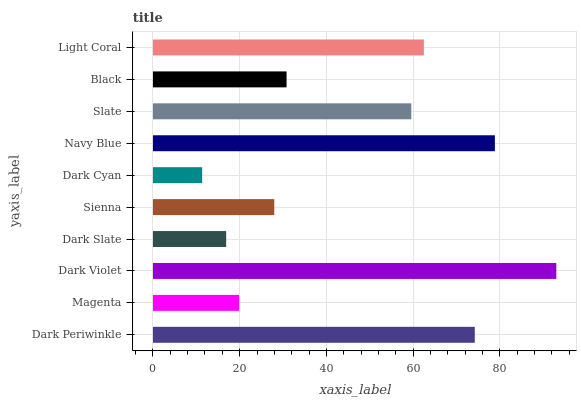Is Dark Cyan the minimum?
Answer yes or no. Yes. Is Dark Violet the maximum?
Answer yes or no. Yes. Is Magenta the minimum?
Answer yes or no. No. Is Magenta the maximum?
Answer yes or no. No. Is Dark Periwinkle greater than Magenta?
Answer yes or no. Yes. Is Magenta less than Dark Periwinkle?
Answer yes or no. Yes. Is Magenta greater than Dark Periwinkle?
Answer yes or no. No. Is Dark Periwinkle less than Magenta?
Answer yes or no. No. Is Slate the high median?
Answer yes or no. Yes. Is Black the low median?
Answer yes or no. Yes. Is Magenta the high median?
Answer yes or no. No. Is Sienna the low median?
Answer yes or no. No. 